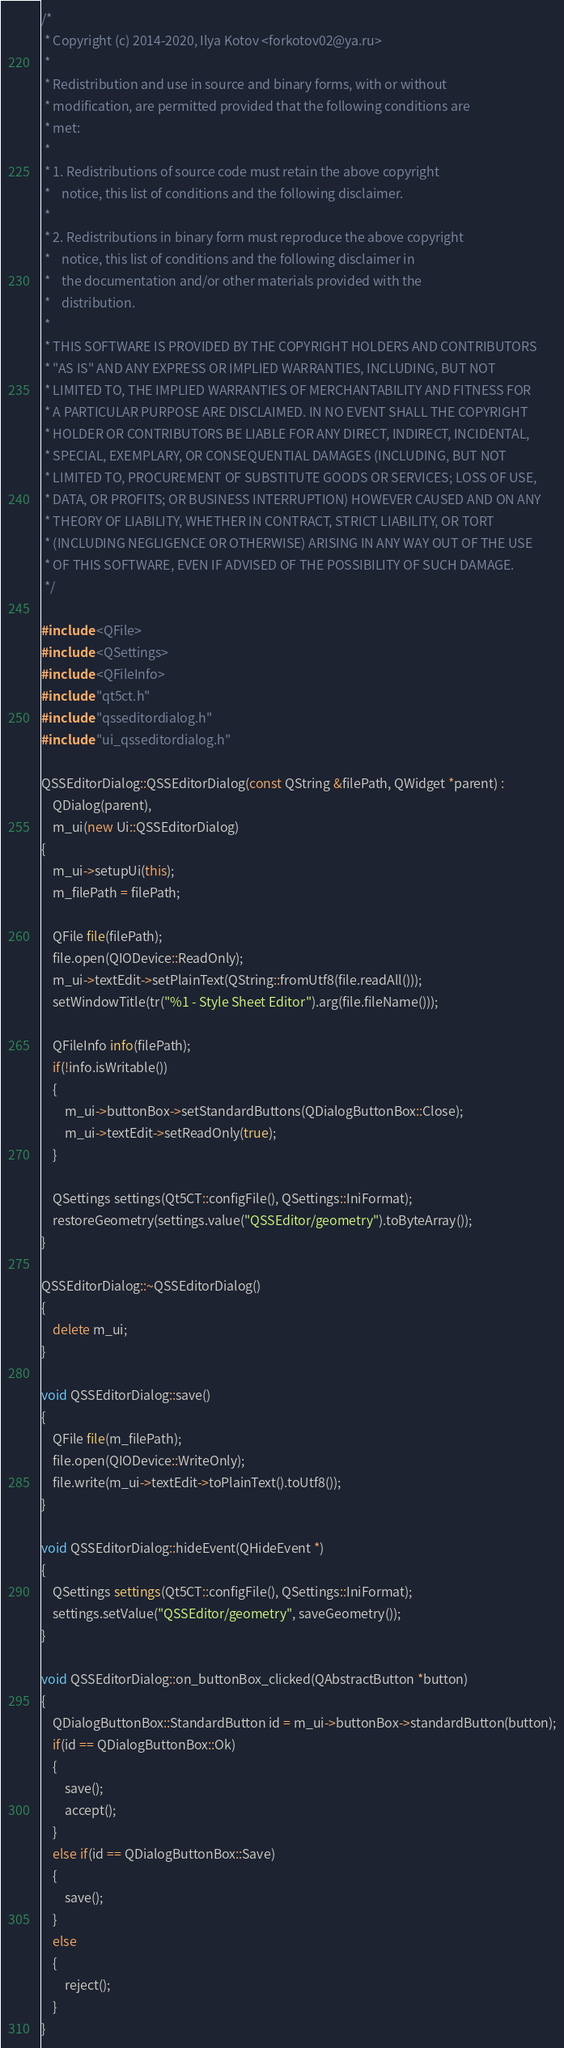<code> <loc_0><loc_0><loc_500><loc_500><_C++_>/*
 * Copyright (c) 2014-2020, Ilya Kotov <forkotov02@ya.ru>
 *
 * Redistribution and use in source and binary forms, with or without
 * modification, are permitted provided that the following conditions are
 * met:
 *
 * 1. Redistributions of source code must retain the above copyright
 *    notice, this list of conditions and the following disclaimer.
 *
 * 2. Redistributions in binary form must reproduce the above copyright
 *    notice, this list of conditions and the following disclaimer in
 *    the documentation and/or other materials provided with the
 *    distribution.
 *
 * THIS SOFTWARE IS PROVIDED BY THE COPYRIGHT HOLDERS AND CONTRIBUTORS
 * "AS IS" AND ANY EXPRESS OR IMPLIED WARRANTIES, INCLUDING, BUT NOT
 * LIMITED TO, THE IMPLIED WARRANTIES OF MERCHANTABILITY AND FITNESS FOR
 * A PARTICULAR PURPOSE ARE DISCLAIMED. IN NO EVENT SHALL THE COPYRIGHT
 * HOLDER OR CONTRIBUTORS BE LIABLE FOR ANY DIRECT, INDIRECT, INCIDENTAL,
 * SPECIAL, EXEMPLARY, OR CONSEQUENTIAL DAMAGES (INCLUDING, BUT NOT
 * LIMITED TO, PROCUREMENT OF SUBSTITUTE GOODS OR SERVICES; LOSS OF USE,
 * DATA, OR PROFITS; OR BUSINESS INTERRUPTION) HOWEVER CAUSED AND ON ANY
 * THEORY OF LIABILITY, WHETHER IN CONTRACT, STRICT LIABILITY, OR TORT
 * (INCLUDING NEGLIGENCE OR OTHERWISE) ARISING IN ANY WAY OUT OF THE USE
 * OF THIS SOFTWARE, EVEN IF ADVISED OF THE POSSIBILITY OF SUCH DAMAGE.
 */

#include <QFile>
#include <QSettings>
#include <QFileInfo>
#include "qt5ct.h"
#include "qsseditordialog.h"
#include "ui_qsseditordialog.h"

QSSEditorDialog::QSSEditorDialog(const QString &filePath, QWidget *parent) :
    QDialog(parent),
    m_ui(new Ui::QSSEditorDialog)
{
    m_ui->setupUi(this);
    m_filePath = filePath;

    QFile file(filePath);
    file.open(QIODevice::ReadOnly);
    m_ui->textEdit->setPlainText(QString::fromUtf8(file.readAll()));
    setWindowTitle(tr("%1 - Style Sheet Editor").arg(file.fileName()));

    QFileInfo info(filePath);
    if(!info.isWritable())
    {
        m_ui->buttonBox->setStandardButtons(QDialogButtonBox::Close);
        m_ui->textEdit->setReadOnly(true);
    }

    QSettings settings(Qt5CT::configFile(), QSettings::IniFormat);
    restoreGeometry(settings.value("QSSEditor/geometry").toByteArray());
}

QSSEditorDialog::~QSSEditorDialog()
{
    delete m_ui;
}

void QSSEditorDialog::save()
{
    QFile file(m_filePath);
    file.open(QIODevice::WriteOnly);
    file.write(m_ui->textEdit->toPlainText().toUtf8());
}

void QSSEditorDialog::hideEvent(QHideEvent *)
{
    QSettings settings(Qt5CT::configFile(), QSettings::IniFormat);
    settings.setValue("QSSEditor/geometry", saveGeometry());
}

void QSSEditorDialog::on_buttonBox_clicked(QAbstractButton *button)
{
    QDialogButtonBox::StandardButton id = m_ui->buttonBox->standardButton(button);
    if(id == QDialogButtonBox::Ok)
    {
        save();
        accept();
    }
    else if(id == QDialogButtonBox::Save)
    {
        save();
    }
    else
    {
        reject();
    }
}
</code> 